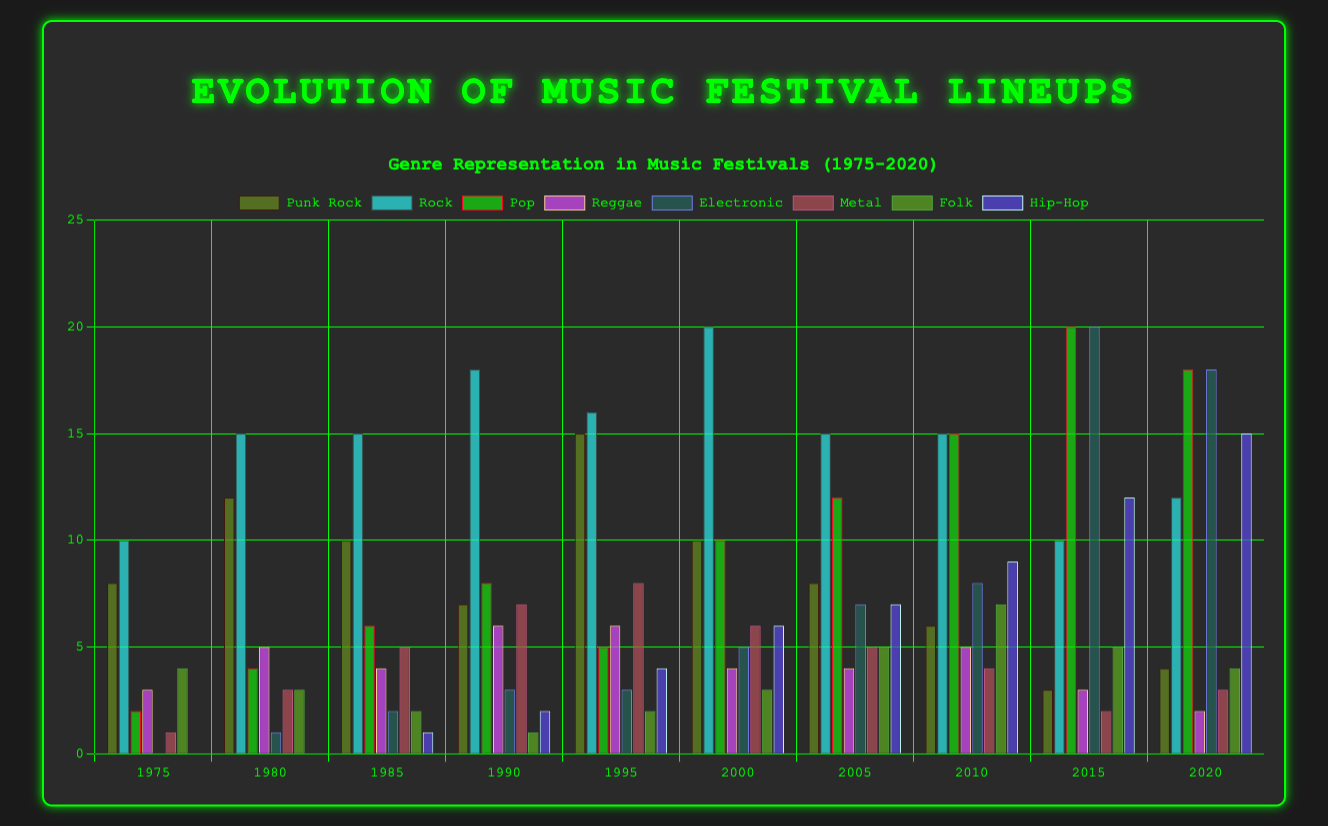What's the overall trend in the representation of Punk Rock from 1975 to 2020? By examining the heights of the Punk Rock bars from 1975 to 2020, we notice a decrease from a peak in 1995 (15) to 2020 (4), indicating a general decline over time.
Answer: Decline Which year had the highest number of Electronic genre representations and how many were there? By observing and comparing the height of the Electronic genre bars across all years, 2015 shows the tallest bar with 20 representations.
Answer: 2015, 20 Which two genres seem to have increased their representation the most from 1975 to 2020? By looking at the bars for each genre over time, Pop and Electronic have the most noticeable increases in height. Pop goes from 2 in 1975 to 18 in 2020, and Electronic goes from 0 in 1975 to 18 in 2020.
Answer: Pop and Electronic In 1980, which genre had the closest representation to Punk Rock in count, and what was the count? Looking at the 1980 grouped bars, Rock had 15, which is closest to Punk Rock's 12.
Answer: Rock, 15 How does the representation of Hip-Hop in 2020 compare to its representation in 2010? Compare the height of the Hip-Hop bar in 2020 (15) to that in 2010 (9); there's an increase.
Answer: Increase Which genre had the highest average representation over the years, and what is that average? By calculating the average height of each genre's bars across the years, Rock stands out. The sum of Rock representations (10+15+15+18+16+20+15+15+10+12) is 146, divided by 10 years gives an average of 14.6.
Answer: Rock, 14.6 What is the difference in the number of metal bands between 1990 and 2005? Comparing the Metal bars in 1990 (7) and 2005 (5), the difference is 2.
Answer: 2 If you were to sum the representation of Folk bands in the years 1980, 2000, and 2010, what would be the total? Adding the heights of the Folk bars: 1980 (3) + 2000 (3) + 2010 (7), we get a total of 13.
Answer: 13 Which year represents the most balanced distribution of genres, and why? The year 2005 has many genres with relatively similar bar heights (values close to each other), suggesting a balanced representation across multiple genres.
Answer: 2005 